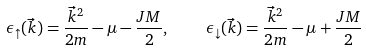Convert formula to latex. <formula><loc_0><loc_0><loc_500><loc_500>\epsilon _ { \uparrow } ( \vec { k } ) = \frac { \vec { k } ^ { 2 } } { 2 m } - \mu - \frac { J M } { 2 } , \quad \, \epsilon _ { \downarrow } ( \vec { k } ) = \frac { \vec { k } ^ { 2 } } { 2 m } - \mu + \frac { J M } { 2 }</formula> 